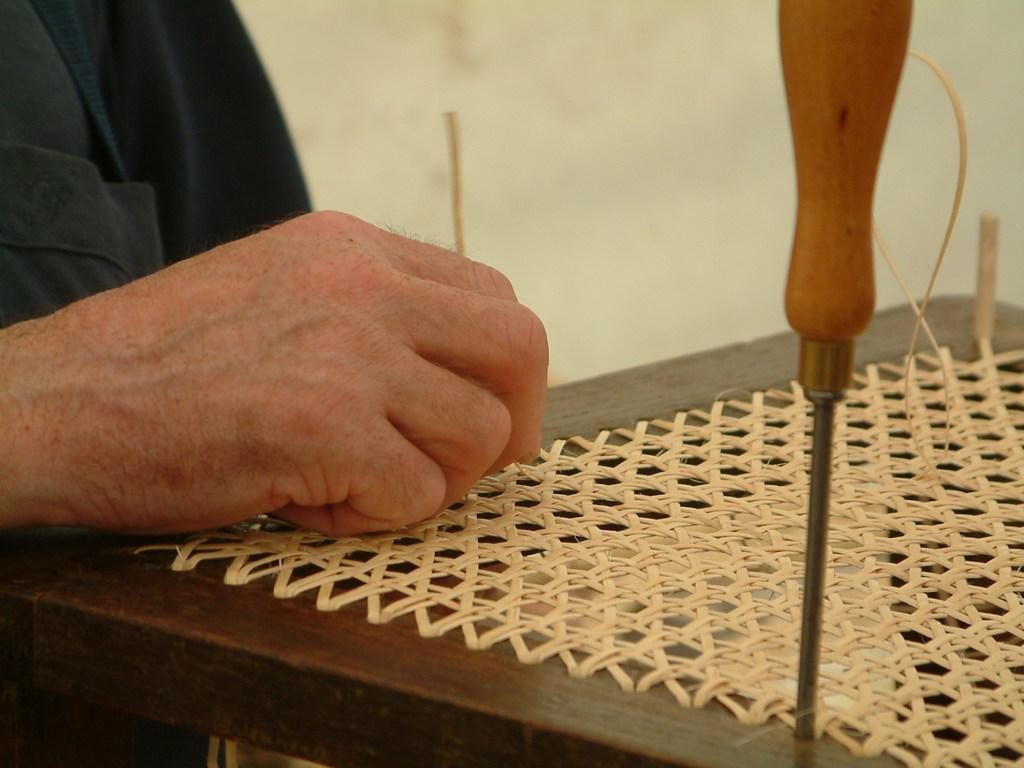What can be seen in the image? There is a person, a tool, and an object in the image. Can you describe the tool in the image? Unfortunately, the specific tool cannot be identified from the provided facts. What is the person doing in the image? The actions of the person cannot be determined from the provided facts. How many giraffes can be seen in the image? There are no giraffes present in the image. What type of pail is being used by the person in the image? There is no mention of a pail in the provided facts, so it cannot be determined if one is present in the image. 